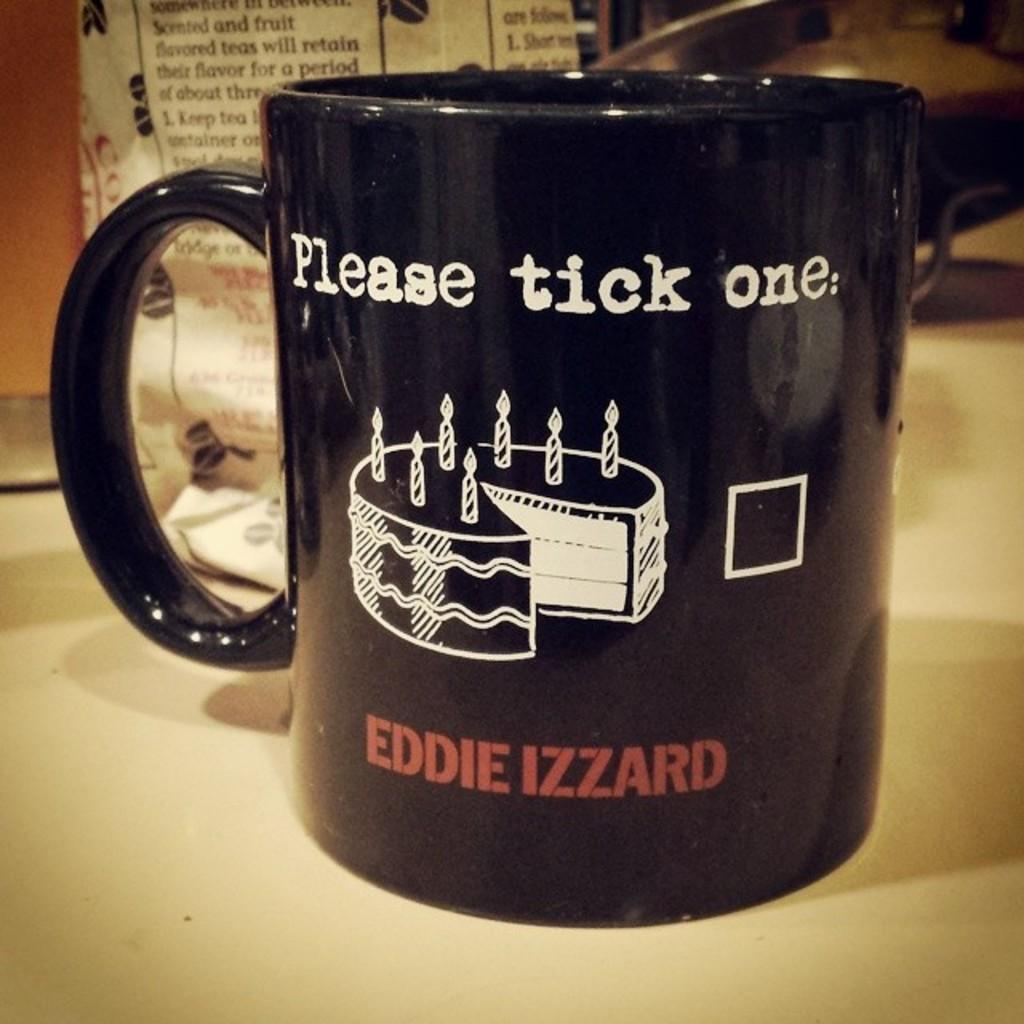<image>
Present a compact description of the photo's key features. black mug which sits on the counter it read please tick one 